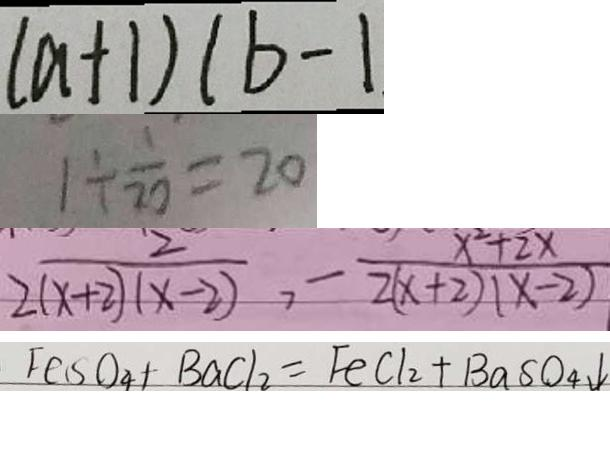<formula> <loc_0><loc_0><loc_500><loc_500>( a + 1 ) ( b - 1 
 1 \div \frac { 1 } { 2 0 } = 2 0 
 \frac { 2 } { 2 ( x + 2 ) ( x - 2 ) } , - \frac { x ^ { 2 } + 2 x } { 2 ( x + 2 ) ( x - 2 ) } 
 F e S O _ { 4 } + B a C l _ { 2 } = F e C l _ { 2 } + B a S O _ { 4 } \downarrow</formula> 